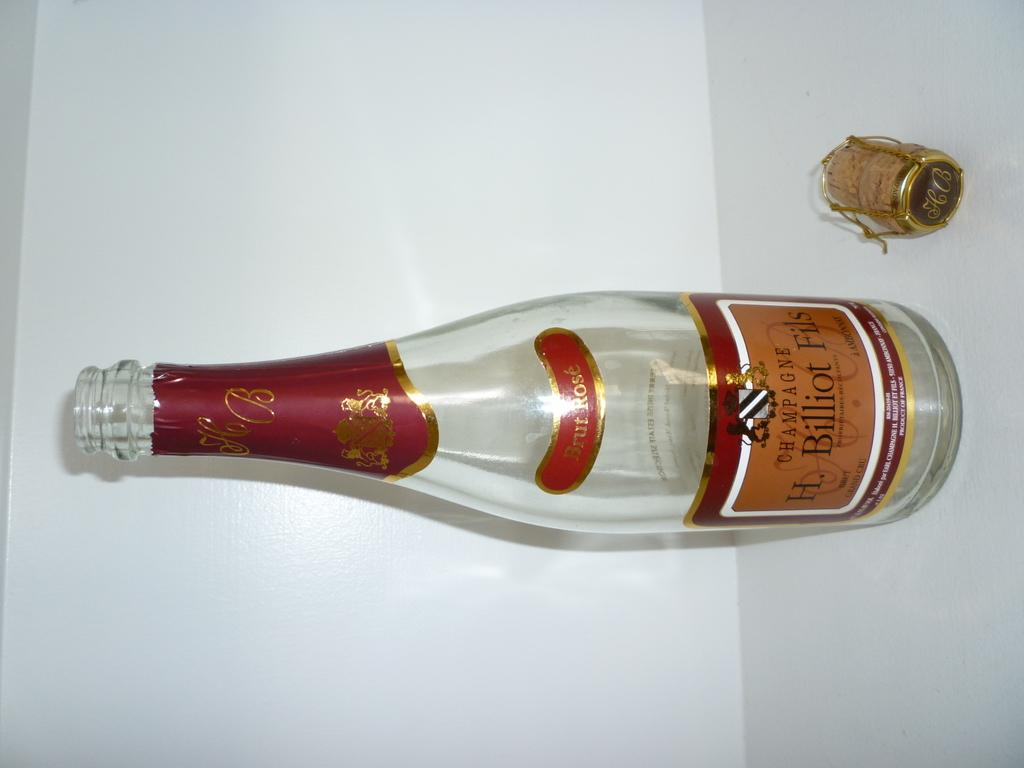What is present in the image that appears to be empty? There is an empty bottle in the image. What can be found on the bottle? The bottle has a label on it. What is located near the empty bottle? There is a cork beside the bottle. Is the person in the image driving a car in a specific direction? There is no person or car present in the image, so it is not possible to answer that question. 